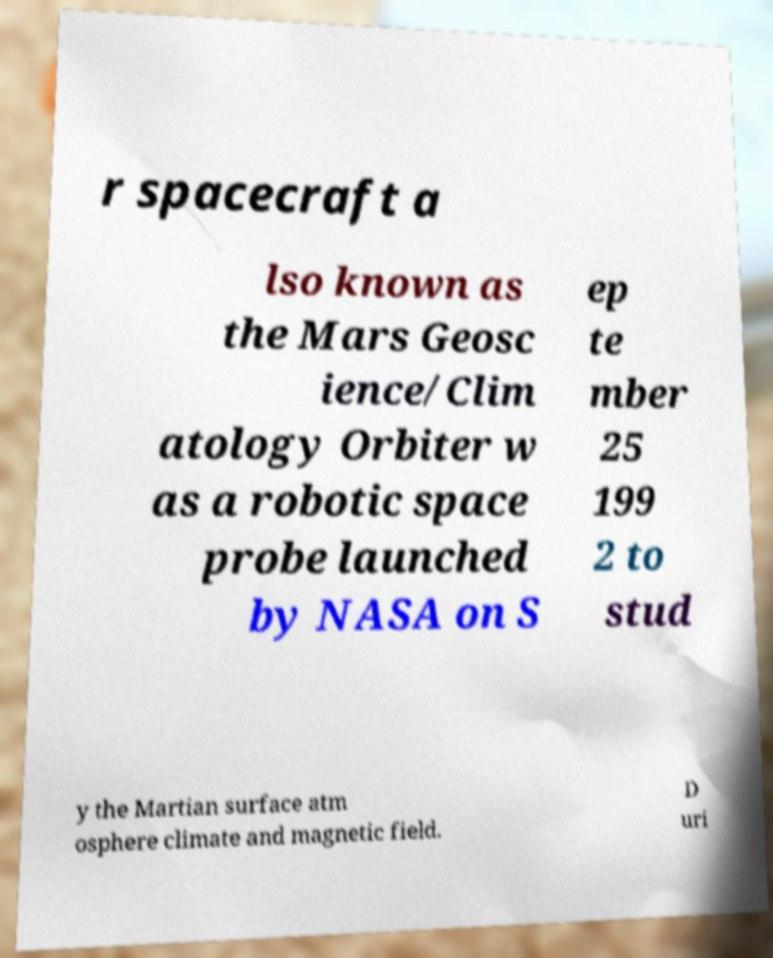Could you extract and type out the text from this image? r spacecraft a lso known as the Mars Geosc ience/Clim atology Orbiter w as a robotic space probe launched by NASA on S ep te mber 25 199 2 to stud y the Martian surface atm osphere climate and magnetic field. D uri 